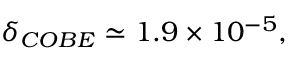<formula> <loc_0><loc_0><loc_500><loc_500>\delta _ { C O B E } \simeq 1 . 9 \times 1 0 ^ { - 5 } ,</formula> 